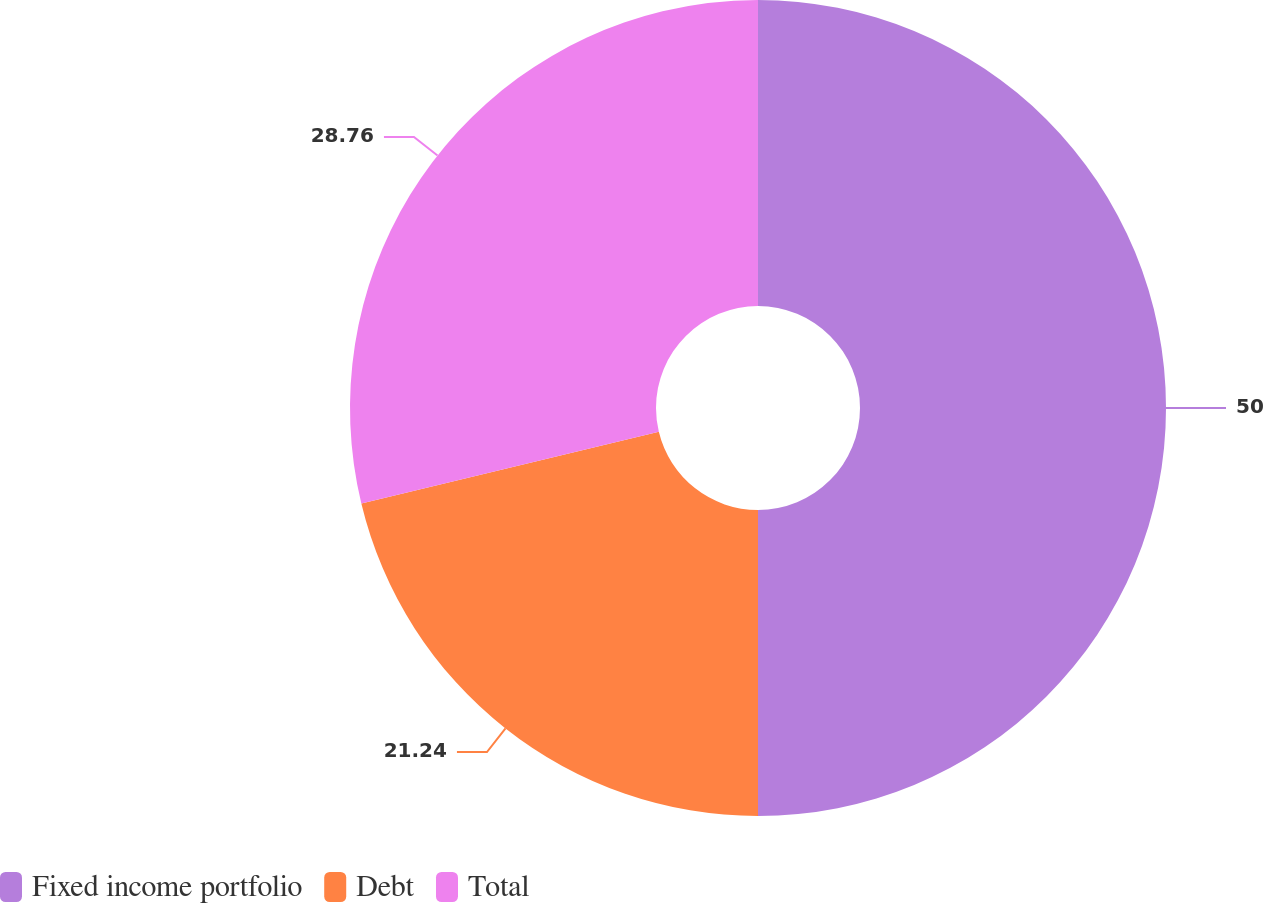Convert chart to OTSL. <chart><loc_0><loc_0><loc_500><loc_500><pie_chart><fcel>Fixed income portfolio<fcel>Debt<fcel>Total<nl><fcel>50.0%<fcel>21.24%<fcel>28.76%<nl></chart> 